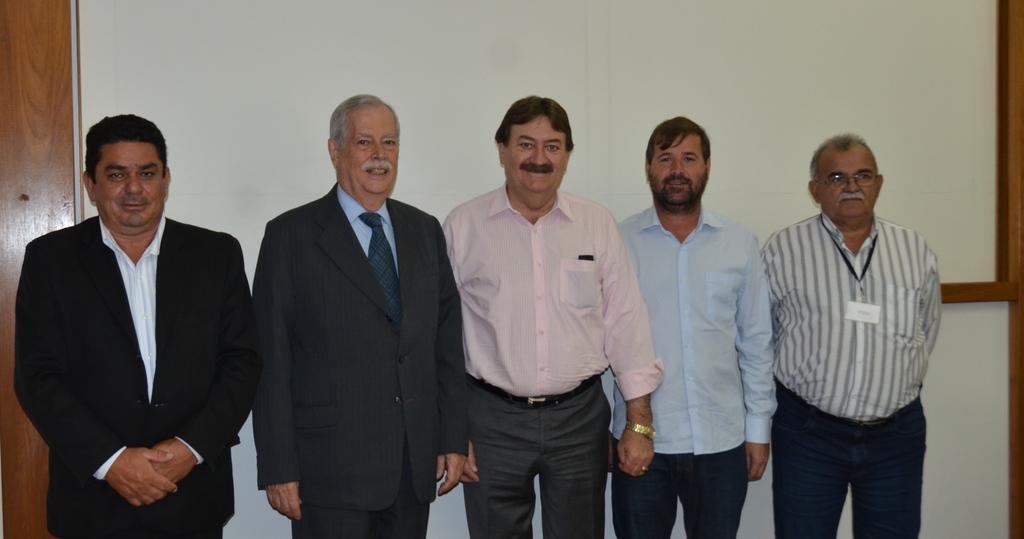Describe this image in one or two sentences. In the middle of the image few people are standing and smiling. Behind them there is wall. 